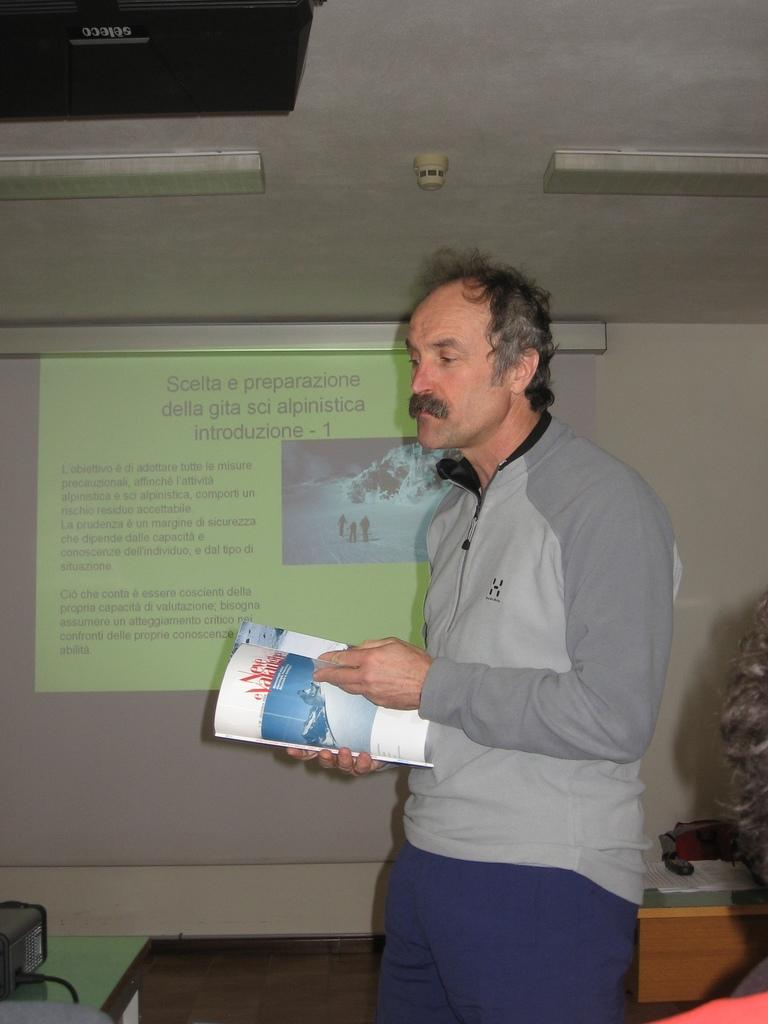Who is present in the image? There is a man in the image. What is the man holding in the image? The man is holding a book. What can be seen in the background of the image? There is a screen and a wall visible in the background of the image. What type of lighting is present in the image? There are lights visible in the image. What type of cover is on the part of the book that the man is holding? There is no information about the cover of the book or which part the man is holding in the image. 